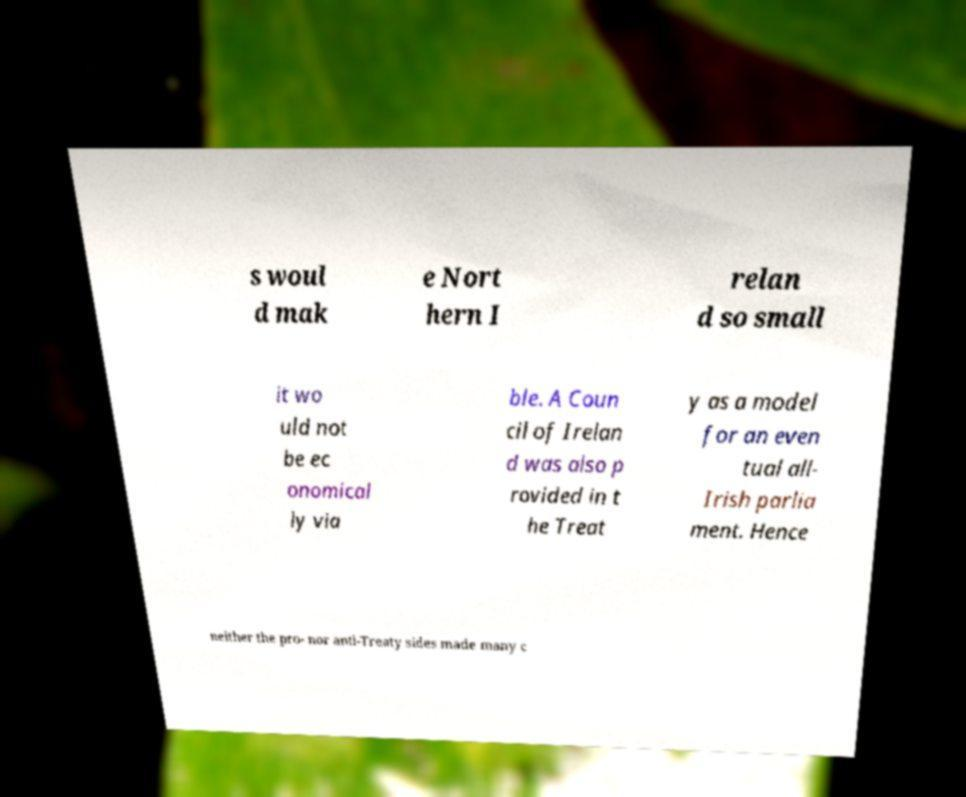Please read and relay the text visible in this image. What does it say? s woul d mak e Nort hern I relan d so small it wo uld not be ec onomical ly via ble. A Coun cil of Irelan d was also p rovided in t he Treat y as a model for an even tual all- Irish parlia ment. Hence neither the pro- nor anti-Treaty sides made many c 